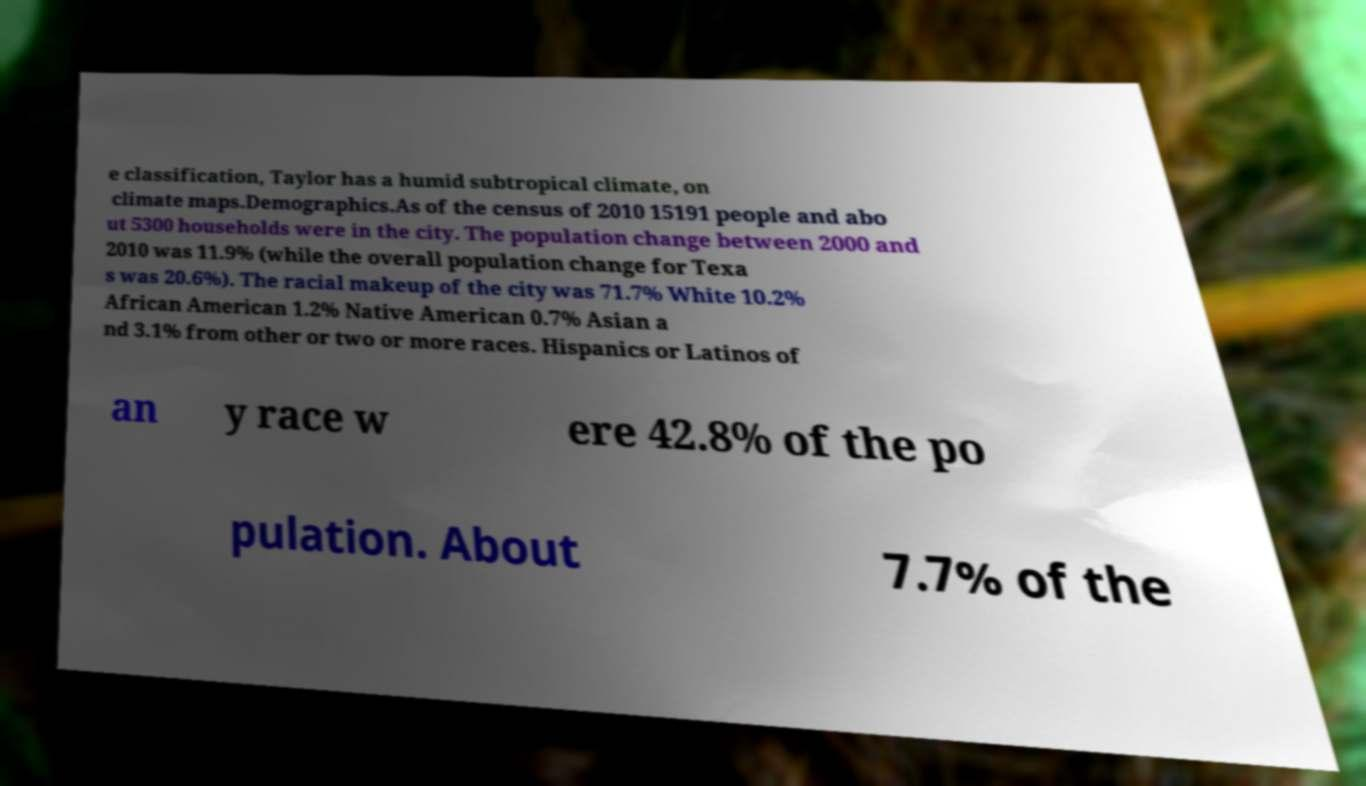What messages or text are displayed in this image? I need them in a readable, typed format. e classification, Taylor has a humid subtropical climate, on climate maps.Demographics.As of the census of 2010 15191 people and abo ut 5300 households were in the city. The population change between 2000 and 2010 was 11.9% (while the overall population change for Texa s was 20.6%). The racial makeup of the city was 71.7% White 10.2% African American 1.2% Native American 0.7% Asian a nd 3.1% from other or two or more races. Hispanics or Latinos of an y race w ere 42.8% of the po pulation. About 7.7% of the 